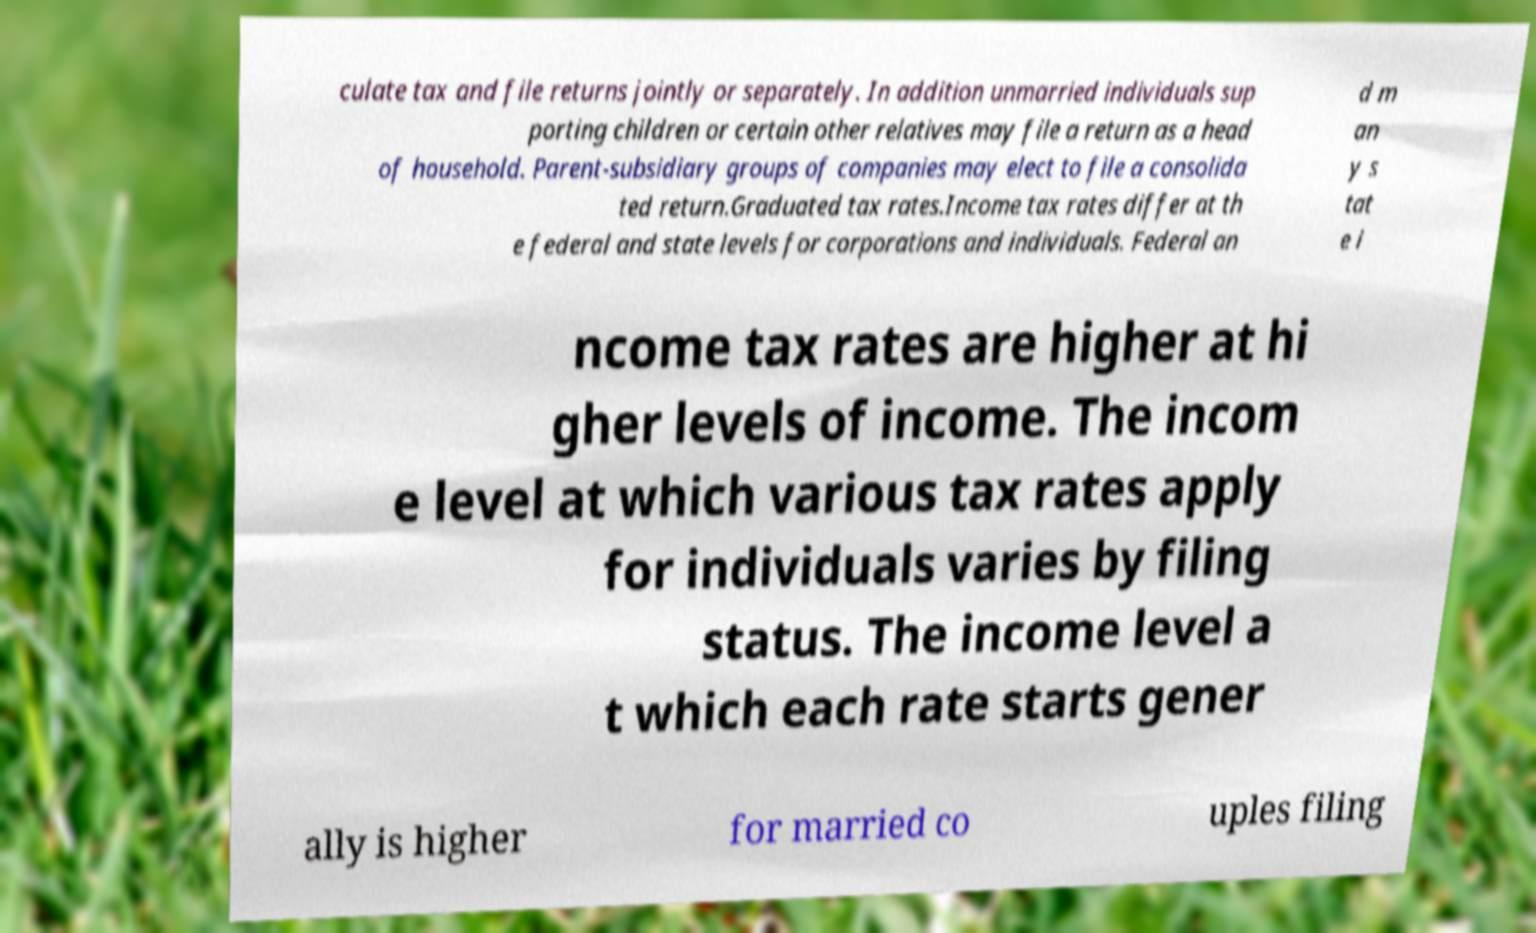Can you accurately transcribe the text from the provided image for me? culate tax and file returns jointly or separately. In addition unmarried individuals sup porting children or certain other relatives may file a return as a head of household. Parent-subsidiary groups of companies may elect to file a consolida ted return.Graduated tax rates.Income tax rates differ at th e federal and state levels for corporations and individuals. Federal an d m an y s tat e i ncome tax rates are higher at hi gher levels of income. The incom e level at which various tax rates apply for individuals varies by filing status. The income level a t which each rate starts gener ally is higher for married co uples filing 